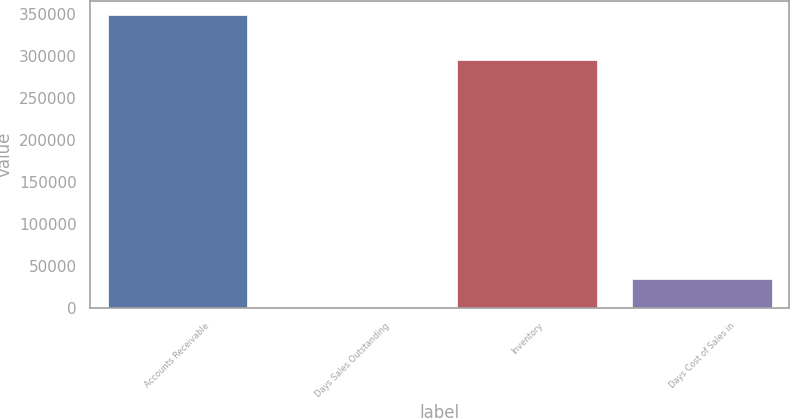Convert chart. <chart><loc_0><loc_0><loc_500><loc_500><bar_chart><fcel>Accounts Receivable<fcel>Days Sales Outstanding<fcel>Inventory<fcel>Days Cost of Sales in<nl><fcel>348416<fcel>44<fcel>295081<fcel>34881.2<nl></chart> 